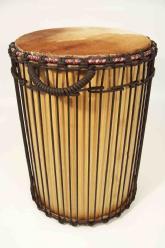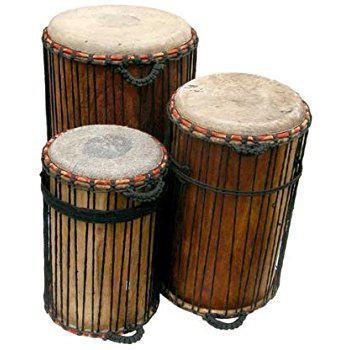The first image is the image on the left, the second image is the image on the right. Analyze the images presented: Is the assertion "One image shows three close-together upright drums, with two standing in front and a bigger one behind them." valid? Answer yes or no. Yes. The first image is the image on the left, the second image is the image on the right. Evaluate the accuracy of this statement regarding the images: "There are at least four drums.". Is it true? Answer yes or no. Yes. 